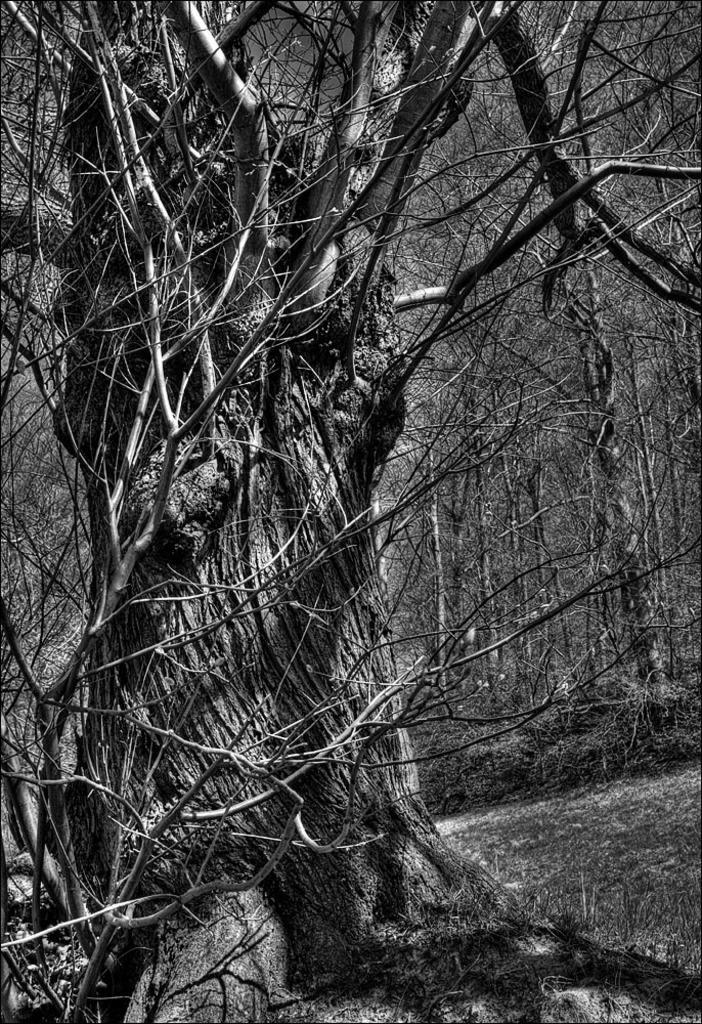In one or two sentences, can you explain what this image depicts? This is a black and white picture, there is a trees in the front on the grassland and behind there are many trees. 